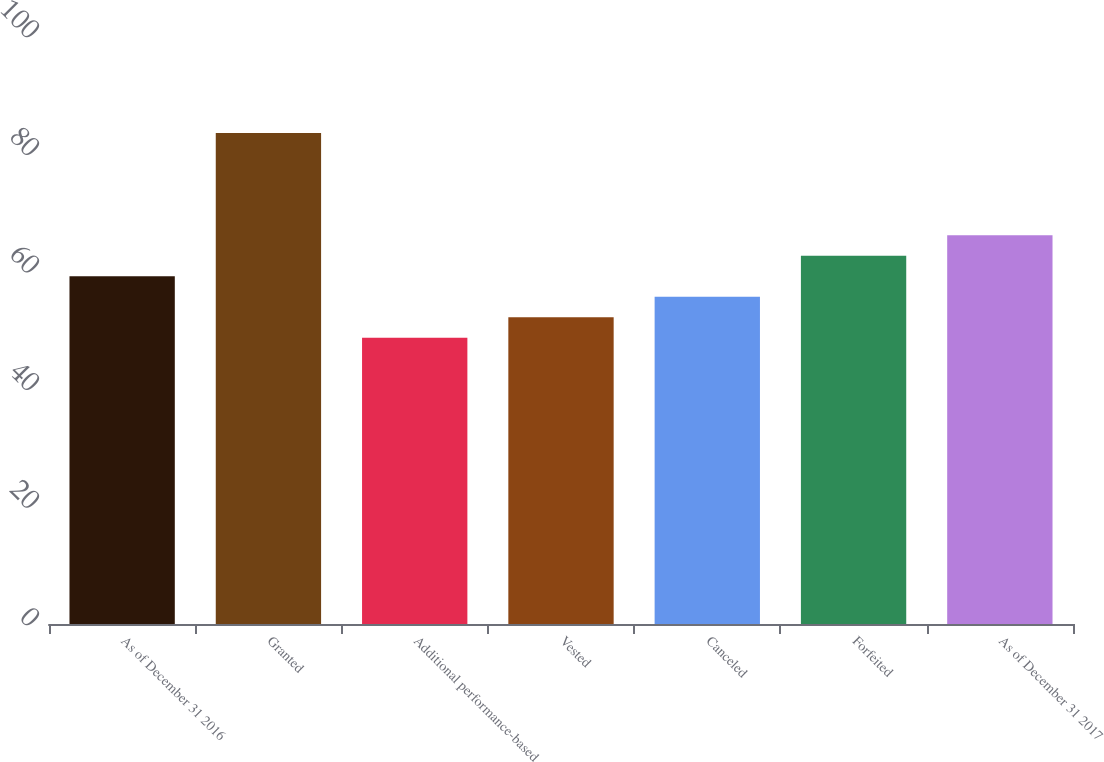Convert chart to OTSL. <chart><loc_0><loc_0><loc_500><loc_500><bar_chart><fcel>As of December 31 2016<fcel>Granted<fcel>Additional performance-based<fcel>Vested<fcel>Canceled<fcel>Forfeited<fcel>As of December 31 2017<nl><fcel>59.14<fcel>83.52<fcel>48.7<fcel>52.18<fcel>55.66<fcel>62.62<fcel>66.1<nl></chart> 